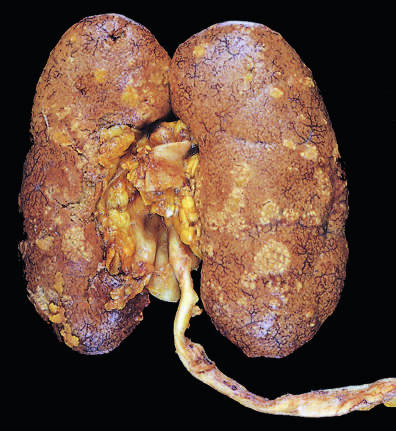s the surrounding lung relatively unaffected?
Answer the question using a single word or phrase. No 